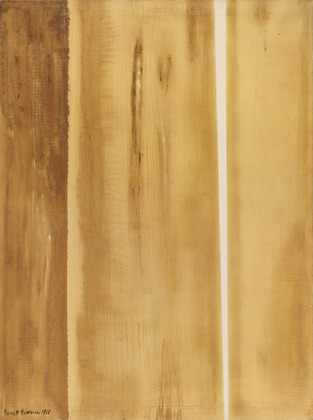Imagine this painting hanging in a specific type of environment. Describe it. The painting would look striking in a minimalist, earthy-toned room with large windows that allow natural light to pour in. Imagine it hanging on an exposed brick wall, the simplicity of the surroundings amplifying the painting’s texture and colors. Subtle, comfortable furniture—perhaps in shades of beige, brown, and green—would enhance the warm, inviting atmosphere. Potted plants, wooden sculptures, and a few handcrafted items would complete the scene, creating a space that feels both modern and connected to nature, perfect for contemplation and relaxation. 